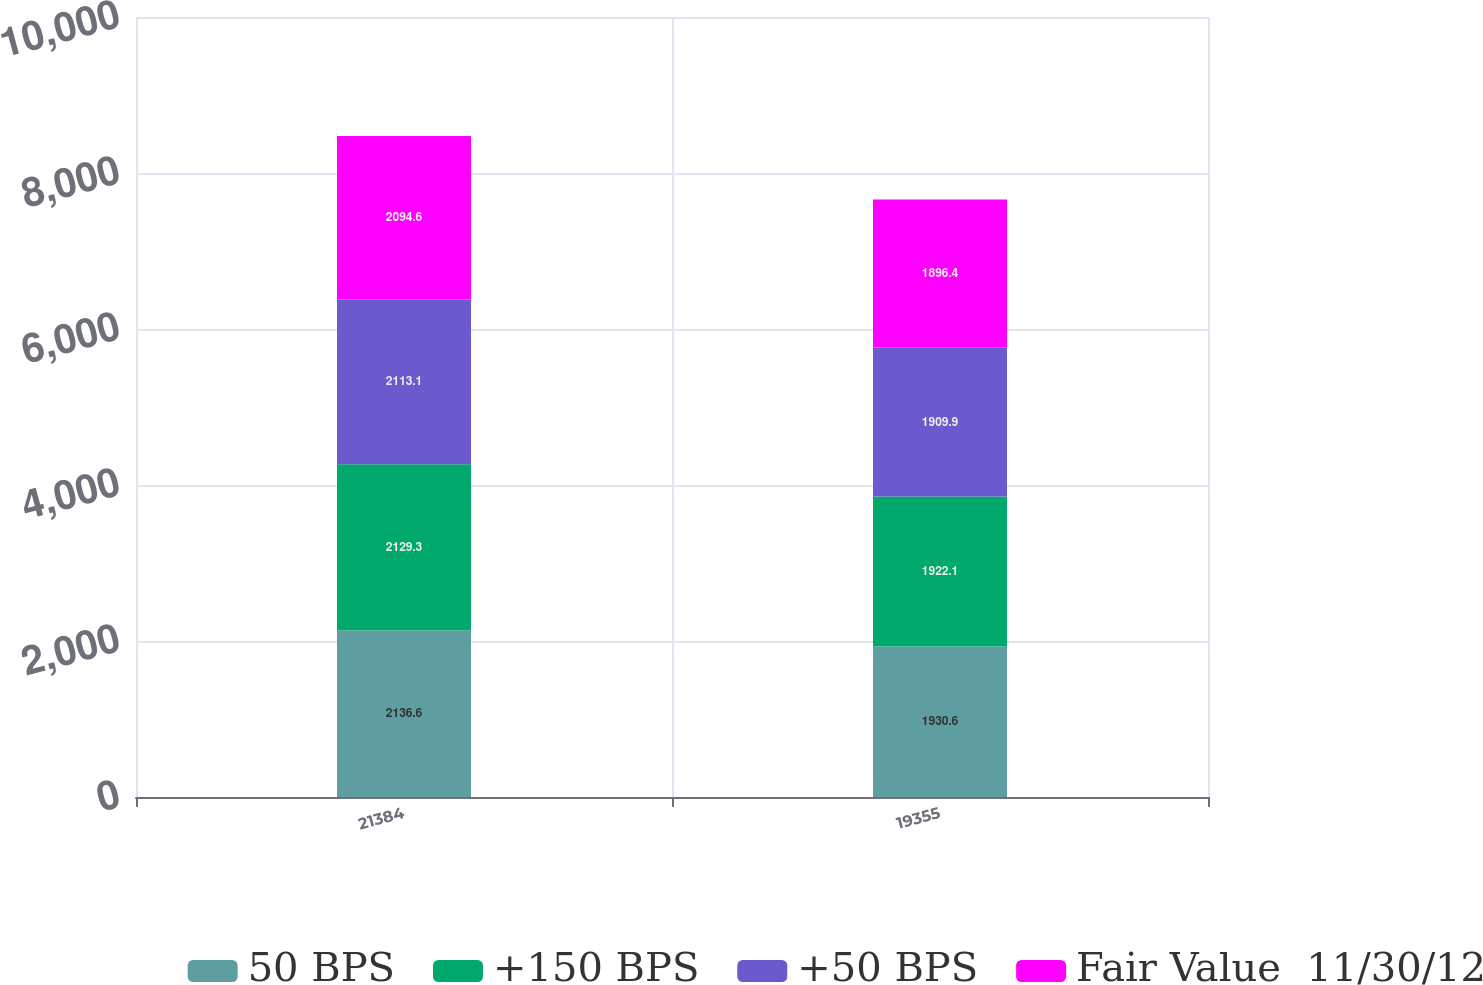<chart> <loc_0><loc_0><loc_500><loc_500><stacked_bar_chart><ecel><fcel>21384<fcel>19355<nl><fcel>50 BPS<fcel>2136.6<fcel>1930.6<nl><fcel>+150 BPS<fcel>2129.3<fcel>1922.1<nl><fcel>+50 BPS<fcel>2113.1<fcel>1909.9<nl><fcel>Fair Value  11/30/12<fcel>2094.6<fcel>1896.4<nl></chart> 